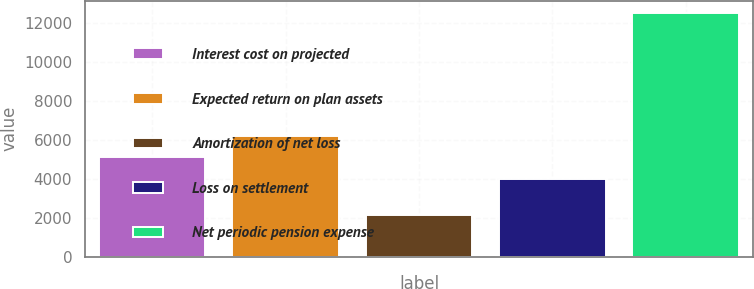Convert chart to OTSL. <chart><loc_0><loc_0><loc_500><loc_500><bar_chart><fcel>Interest cost on projected<fcel>Expected return on plan assets<fcel>Amortization of net loss<fcel>Loss on settlement<fcel>Net periodic pension expense<nl><fcel>5125<fcel>6162.1<fcel>2126<fcel>3951<fcel>12497<nl></chart> 